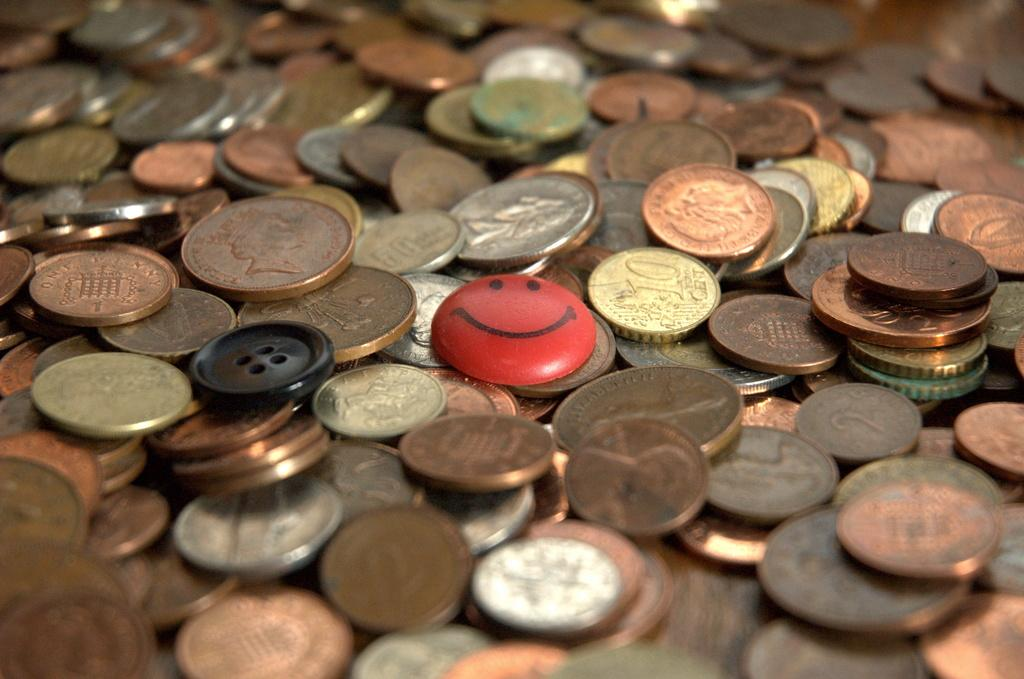What type of objects are in the image? There is a group of coins and a smiley badge in the image. Where are the coins and the badge located? Both the coins and the badge are on a platform. What type of shoe is visible in the image? There is no shoe present in the image. 